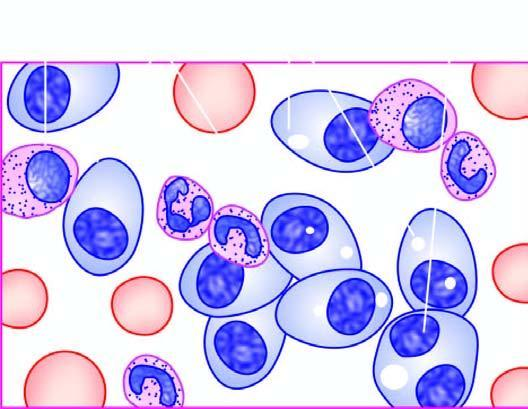what do bone marrow aspirate in myeloma show?
Answer the question using a single word or phrase. Numerous plasma cells 